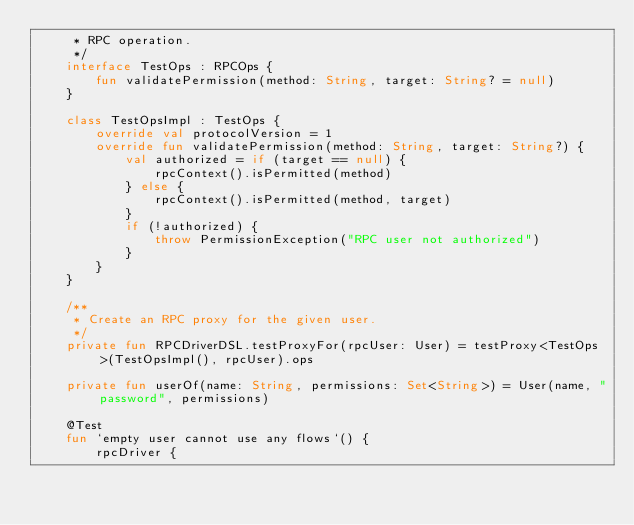<code> <loc_0><loc_0><loc_500><loc_500><_Kotlin_>     * RPC operation.
     */
    interface TestOps : RPCOps {
        fun validatePermission(method: String, target: String? = null)
    }

    class TestOpsImpl : TestOps {
        override val protocolVersion = 1
        override fun validatePermission(method: String, target: String?) {
            val authorized = if (target == null) {
                rpcContext().isPermitted(method)
            } else {
                rpcContext().isPermitted(method, target)
            }
            if (!authorized) {
                throw PermissionException("RPC user not authorized")
            }
        }
    }

    /**
     * Create an RPC proxy for the given user.
     */
    private fun RPCDriverDSL.testProxyFor(rpcUser: User) = testProxy<TestOps>(TestOpsImpl(), rpcUser).ops

    private fun userOf(name: String, permissions: Set<String>) = User(name, "password", permissions)

    @Test
    fun `empty user cannot use any flows`() {
        rpcDriver {</code> 